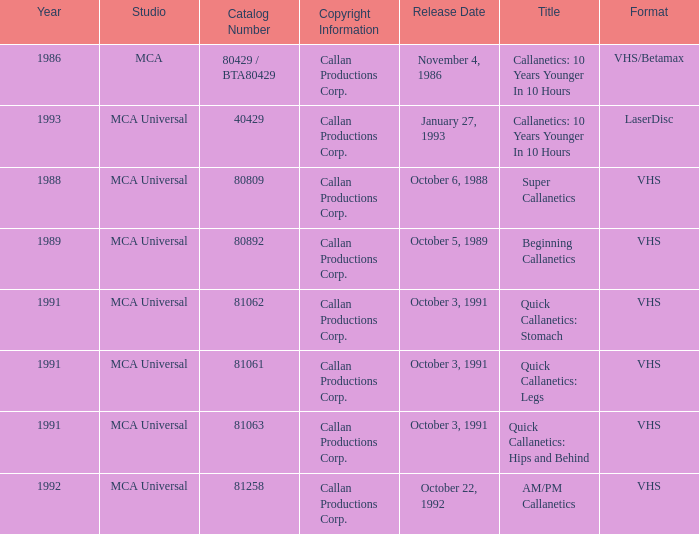Name the format for super callanetics VHS. Parse the full table. {'header': ['Year', 'Studio', 'Catalog Number', 'Copyright Information', 'Release Date', 'Title', 'Format'], 'rows': [['1986', 'MCA', '80429 / BTA80429', 'Callan Productions Corp.', 'November 4, 1986', 'Callanetics: 10 Years Younger In 10 Hours', 'VHS/Betamax'], ['1993', 'MCA Universal', '40429', 'Callan Productions Corp.', 'January 27, 1993', 'Callanetics: 10 Years Younger In 10 Hours', 'LaserDisc'], ['1988', 'MCA Universal', '80809', 'Callan Productions Corp.', 'October 6, 1988', 'Super Callanetics', 'VHS'], ['1989', 'MCA Universal', '80892', 'Callan Productions Corp.', 'October 5, 1989', 'Beginning Callanetics', 'VHS'], ['1991', 'MCA Universal', '81062', 'Callan Productions Corp.', 'October 3, 1991', 'Quick Callanetics: Stomach', 'VHS'], ['1991', 'MCA Universal', '81061', 'Callan Productions Corp.', 'October 3, 1991', 'Quick Callanetics: Legs', 'VHS'], ['1991', 'MCA Universal', '81063', 'Callan Productions Corp.', 'October 3, 1991', 'Quick Callanetics: Hips and Behind', 'VHS'], ['1992', 'MCA Universal', '81258', 'Callan Productions Corp.', 'October 22, 1992', 'AM/PM Callanetics', 'VHS']]} 